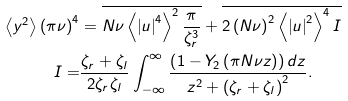Convert formula to latex. <formula><loc_0><loc_0><loc_500><loc_500>\left \langle y ^ { 2 } \right \rangle \left ( \pi \nu \right ) ^ { 4 } & = \overline { N \nu \left \langle \left | u \right | ^ { 4 } \right \rangle ^ { 2 } \frac { \pi } { \zeta _ { r } ^ { 3 } } } + \overline { 2 \left ( N \nu \right ) ^ { 2 } \left \langle \left | u \right | ^ { 2 } \right \rangle ^ { 4 } I } \\ I = & \frac { \zeta _ { r } + \zeta _ { l } } { 2 \zeta _ { r } \zeta _ { l } } \int _ { - \infty } ^ { \infty } \frac { \left ( 1 - Y _ { 2 } \left ( \pi N \nu z \right ) \right ) d z } { z ^ { 2 } + \left ( \zeta _ { r } + \zeta _ { l } \right ) ^ { 2 } } .</formula> 